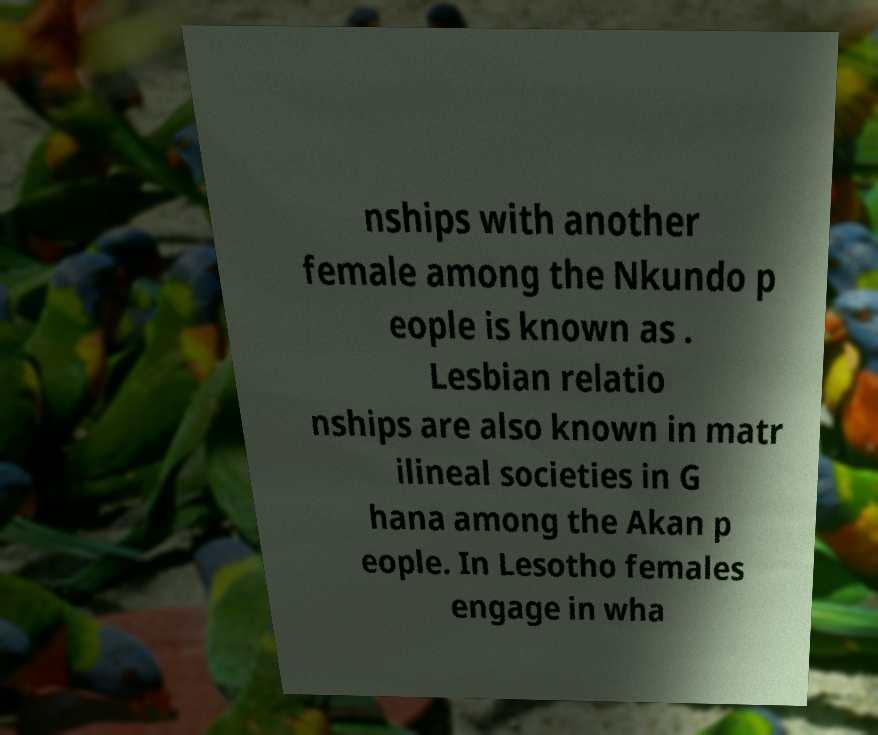Please read and relay the text visible in this image. What does it say? nships with another female among the Nkundo p eople is known as . Lesbian relatio nships are also known in matr ilineal societies in G hana among the Akan p eople. In Lesotho females engage in wha 